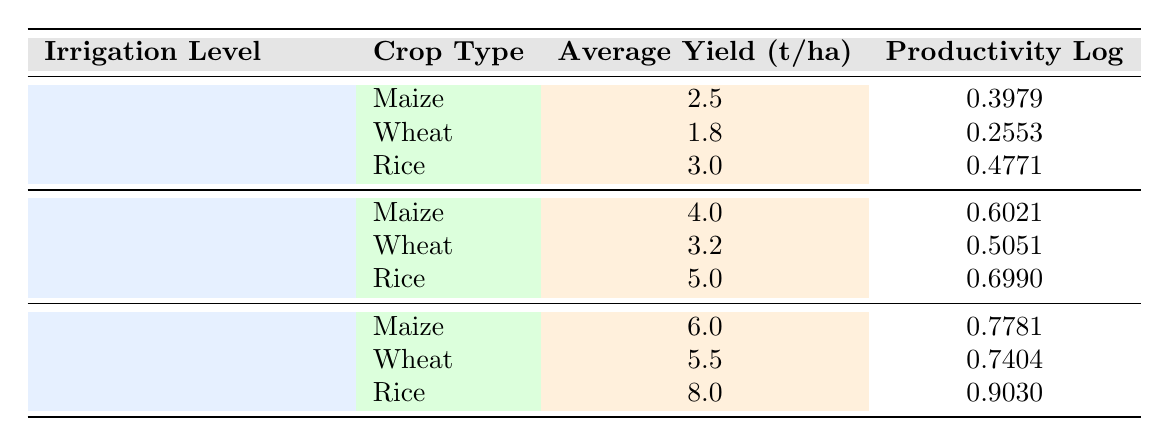What is the average yield for Maize at high irrigation levels? The average yield for Maize at high irrigation levels (7-9 mm/day) is 6.0 t/ha, as noted in the relevant row of the table.
Answer: 6.0 t/ha How many crops show an average yield above 5.0 t/ha? By examining the table, the crops that meet this criterion are Rice (8.0 t/ha) and Maize (6.0 t/ha) at high irrigation levels. Thus, there are 2 crops.
Answer: 2 crops Is the average yield for Wheat at moderate irrigation levels greater than that at low irrigation levels? The average yield for Wheat at moderate irrigation levels (3.2 t/ha) is compared with low irrigation levels (1.8 t/ha). Since 3.2 is indeed greater than 1.8, the statement is true.
Answer: Yes What is the difference in average yield for Rice between low and high irrigation levels? The average yield for Rice at low irrigation levels is 3.0 t/ha and at high irrigation levels is 8.0 t/ha. The difference is calculated as 8.0 - 3.0 = 5.0 t/ha.
Answer: 5.0 t/ha Which irrigation level yields the highest productivity log for Wheat? Reviewing the table, the irrigation level for Wheat that has the highest productivity log is high irrigation (7-9 mm/day) with a log value of 0.7404, compared to others.
Answer: High (7-9 mm/day) What is the combined average yield for all crops at moderate irrigation levels? At moderate irrigation levels, the average yields are 4.0 t/ha for Maize, 3.2 t/ha for Wheat, and 5.0 t/ha for Rice. The total is 4.0 + 3.2 + 5.0 = 12.2 t/ha, and the average for three crops is 12.2 / 3 = 4.07 t/ha.
Answer: 4.07 t/ha Is it true that all crops have a higher average yield at high irrigation levels compared to low irrigation levels? Looking at the average yields: Maize shows 6.0 t/ha at high and 2.5 t/ha at low; Wheat shows 5.5 t/ha at high and 1.8 t/ha at low; and Rice shows 8.0 t/ha at high and 3.0 t/ha at low. Since all were higher at high irrigation levels, the answer is true.
Answer: Yes If Rice has an average yield of 8.0 t/ha at high irrigation levels, what would the productivity log be? According to the table, at high irrigation levels, the productivity log for Rice is 0.9030. Therefore, this value reflects the productivity log directly associated with the yield of 8.0 t/ha.
Answer: 0.9030 